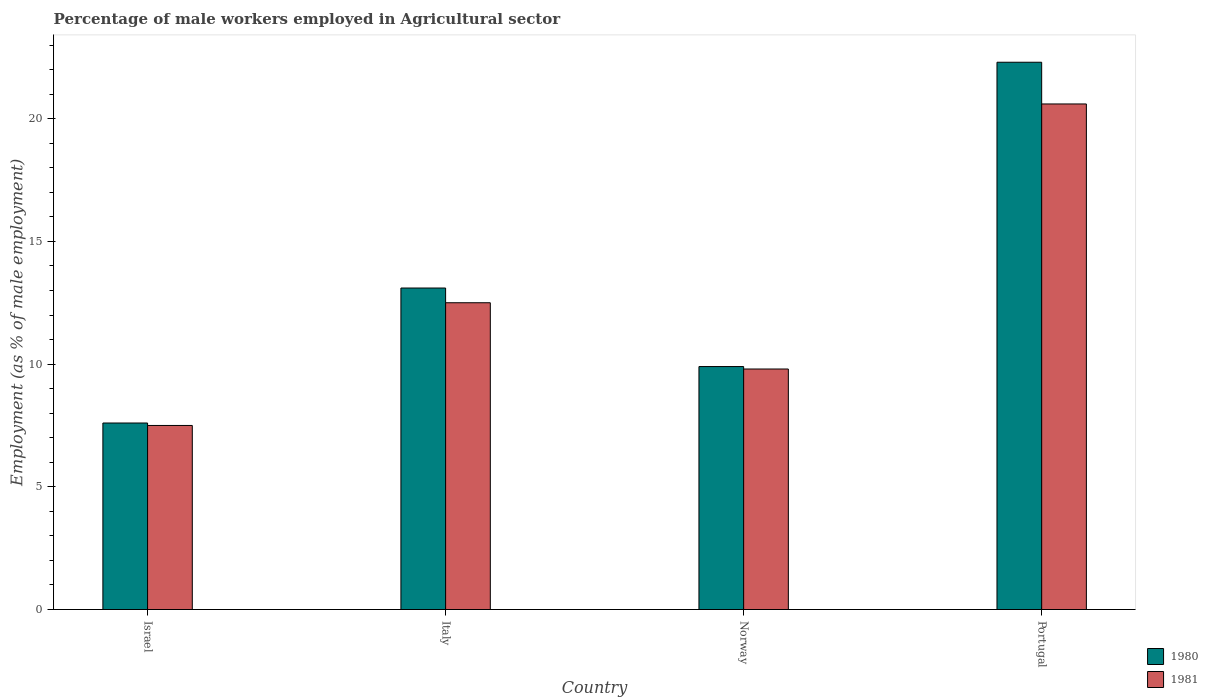How many different coloured bars are there?
Your response must be concise. 2. How many bars are there on the 4th tick from the left?
Your response must be concise. 2. How many bars are there on the 4th tick from the right?
Give a very brief answer. 2. What is the label of the 1st group of bars from the left?
Offer a very short reply. Israel. In how many cases, is the number of bars for a given country not equal to the number of legend labels?
Your answer should be compact. 0. What is the percentage of male workers employed in Agricultural sector in 1981 in Israel?
Provide a short and direct response. 7.5. Across all countries, what is the maximum percentage of male workers employed in Agricultural sector in 1980?
Give a very brief answer. 22.3. Across all countries, what is the minimum percentage of male workers employed in Agricultural sector in 1980?
Ensure brevity in your answer.  7.6. In which country was the percentage of male workers employed in Agricultural sector in 1980 maximum?
Make the answer very short. Portugal. In which country was the percentage of male workers employed in Agricultural sector in 1981 minimum?
Ensure brevity in your answer.  Israel. What is the total percentage of male workers employed in Agricultural sector in 1981 in the graph?
Ensure brevity in your answer.  50.4. What is the difference between the percentage of male workers employed in Agricultural sector in 1980 in Italy and that in Portugal?
Your response must be concise. -9.2. What is the difference between the percentage of male workers employed in Agricultural sector in 1980 in Portugal and the percentage of male workers employed in Agricultural sector in 1981 in Israel?
Offer a very short reply. 14.8. What is the average percentage of male workers employed in Agricultural sector in 1981 per country?
Your answer should be compact. 12.6. What is the difference between the percentage of male workers employed in Agricultural sector of/in 1981 and percentage of male workers employed in Agricultural sector of/in 1980 in Portugal?
Offer a terse response. -1.7. What is the ratio of the percentage of male workers employed in Agricultural sector in 1981 in Israel to that in Portugal?
Your response must be concise. 0.36. What is the difference between the highest and the second highest percentage of male workers employed in Agricultural sector in 1981?
Keep it short and to the point. -10.8. What is the difference between the highest and the lowest percentage of male workers employed in Agricultural sector in 1981?
Offer a terse response. 13.1. In how many countries, is the percentage of male workers employed in Agricultural sector in 1981 greater than the average percentage of male workers employed in Agricultural sector in 1981 taken over all countries?
Keep it short and to the point. 1. What does the 1st bar from the left in Israel represents?
Keep it short and to the point. 1980. What does the 1st bar from the right in Portugal represents?
Provide a succinct answer. 1981. How many bars are there?
Ensure brevity in your answer.  8. How many countries are there in the graph?
Keep it short and to the point. 4. What is the difference between two consecutive major ticks on the Y-axis?
Keep it short and to the point. 5. Are the values on the major ticks of Y-axis written in scientific E-notation?
Offer a very short reply. No. Does the graph contain any zero values?
Make the answer very short. No. Does the graph contain grids?
Your answer should be compact. No. What is the title of the graph?
Your response must be concise. Percentage of male workers employed in Agricultural sector. Does "2000" appear as one of the legend labels in the graph?
Provide a succinct answer. No. What is the label or title of the Y-axis?
Offer a terse response. Employment (as % of male employment). What is the Employment (as % of male employment) of 1980 in Israel?
Provide a succinct answer. 7.6. What is the Employment (as % of male employment) in 1981 in Israel?
Your response must be concise. 7.5. What is the Employment (as % of male employment) in 1980 in Italy?
Give a very brief answer. 13.1. What is the Employment (as % of male employment) in 1980 in Norway?
Offer a very short reply. 9.9. What is the Employment (as % of male employment) of 1981 in Norway?
Your answer should be very brief. 9.8. What is the Employment (as % of male employment) in 1980 in Portugal?
Your answer should be very brief. 22.3. What is the Employment (as % of male employment) of 1981 in Portugal?
Ensure brevity in your answer.  20.6. Across all countries, what is the maximum Employment (as % of male employment) in 1980?
Provide a succinct answer. 22.3. Across all countries, what is the maximum Employment (as % of male employment) in 1981?
Your response must be concise. 20.6. Across all countries, what is the minimum Employment (as % of male employment) in 1980?
Give a very brief answer. 7.6. Across all countries, what is the minimum Employment (as % of male employment) in 1981?
Make the answer very short. 7.5. What is the total Employment (as % of male employment) of 1980 in the graph?
Your response must be concise. 52.9. What is the total Employment (as % of male employment) of 1981 in the graph?
Provide a succinct answer. 50.4. What is the difference between the Employment (as % of male employment) of 1980 in Israel and that in Italy?
Your answer should be compact. -5.5. What is the difference between the Employment (as % of male employment) of 1980 in Israel and that in Norway?
Offer a terse response. -2.3. What is the difference between the Employment (as % of male employment) in 1981 in Israel and that in Norway?
Keep it short and to the point. -2.3. What is the difference between the Employment (as % of male employment) in 1980 in Israel and that in Portugal?
Your answer should be compact. -14.7. What is the difference between the Employment (as % of male employment) in 1981 in Italy and that in Norway?
Offer a terse response. 2.7. What is the difference between the Employment (as % of male employment) of 1980 in Italy and that in Portugal?
Your response must be concise. -9.2. What is the difference between the Employment (as % of male employment) in 1981 in Norway and that in Portugal?
Provide a succinct answer. -10.8. What is the difference between the Employment (as % of male employment) of 1980 in Israel and the Employment (as % of male employment) of 1981 in Italy?
Offer a very short reply. -4.9. What is the difference between the Employment (as % of male employment) in 1980 in Italy and the Employment (as % of male employment) in 1981 in Norway?
Your response must be concise. 3.3. What is the difference between the Employment (as % of male employment) in 1980 in Norway and the Employment (as % of male employment) in 1981 in Portugal?
Ensure brevity in your answer.  -10.7. What is the average Employment (as % of male employment) of 1980 per country?
Make the answer very short. 13.22. What is the average Employment (as % of male employment) of 1981 per country?
Give a very brief answer. 12.6. What is the difference between the Employment (as % of male employment) of 1980 and Employment (as % of male employment) of 1981 in Israel?
Your response must be concise. 0.1. What is the difference between the Employment (as % of male employment) of 1980 and Employment (as % of male employment) of 1981 in Norway?
Give a very brief answer. 0.1. What is the ratio of the Employment (as % of male employment) of 1980 in Israel to that in Italy?
Your answer should be very brief. 0.58. What is the ratio of the Employment (as % of male employment) of 1981 in Israel to that in Italy?
Your answer should be very brief. 0.6. What is the ratio of the Employment (as % of male employment) of 1980 in Israel to that in Norway?
Keep it short and to the point. 0.77. What is the ratio of the Employment (as % of male employment) of 1981 in Israel to that in Norway?
Your response must be concise. 0.77. What is the ratio of the Employment (as % of male employment) in 1980 in Israel to that in Portugal?
Your answer should be very brief. 0.34. What is the ratio of the Employment (as % of male employment) of 1981 in Israel to that in Portugal?
Your response must be concise. 0.36. What is the ratio of the Employment (as % of male employment) in 1980 in Italy to that in Norway?
Offer a terse response. 1.32. What is the ratio of the Employment (as % of male employment) of 1981 in Italy to that in Norway?
Provide a short and direct response. 1.28. What is the ratio of the Employment (as % of male employment) of 1980 in Italy to that in Portugal?
Ensure brevity in your answer.  0.59. What is the ratio of the Employment (as % of male employment) of 1981 in Italy to that in Portugal?
Your response must be concise. 0.61. What is the ratio of the Employment (as % of male employment) in 1980 in Norway to that in Portugal?
Give a very brief answer. 0.44. What is the ratio of the Employment (as % of male employment) of 1981 in Norway to that in Portugal?
Provide a short and direct response. 0.48. What is the difference between the highest and the second highest Employment (as % of male employment) in 1980?
Your answer should be very brief. 9.2. What is the difference between the highest and the second highest Employment (as % of male employment) in 1981?
Provide a succinct answer. 8.1. 